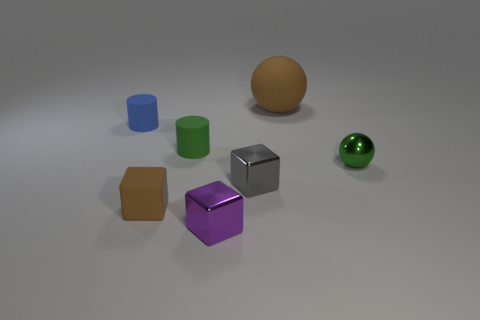Add 3 large blue rubber spheres. How many objects exist? 10 Subtract all tiny metallic cubes. How many cubes are left? 1 Subtract 2 blocks. How many blocks are left? 1 Subtract all purple blocks. How many blocks are left? 2 Subtract 1 gray blocks. How many objects are left? 6 Subtract all cylinders. How many objects are left? 5 Subtract all green cylinders. Subtract all green spheres. How many cylinders are left? 1 Subtract all brown blocks. How many blue cylinders are left? 1 Subtract all big balls. Subtract all tiny things. How many objects are left? 0 Add 4 small purple metal things. How many small purple metal things are left? 5 